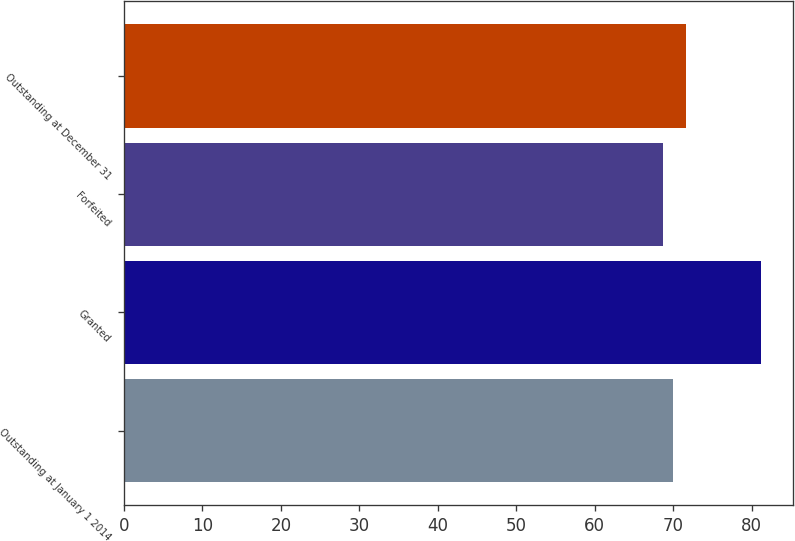Convert chart to OTSL. <chart><loc_0><loc_0><loc_500><loc_500><bar_chart><fcel>Outstanding at January 1 2014<fcel>Granted<fcel>Forfeited<fcel>Outstanding at December 31<nl><fcel>69.99<fcel>81.2<fcel>68.74<fcel>71.58<nl></chart> 